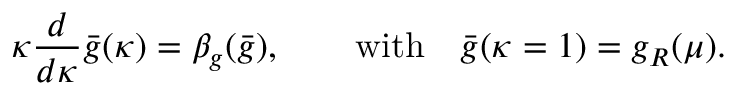Convert formula to latex. <formula><loc_0><loc_0><loc_500><loc_500>\kappa \frac { d } { d \kappa } \bar { g } ( \kappa ) = \beta _ { g } ( \bar { g } ) , \quad w i t h \quad \bar { g } ( \kappa = 1 ) = g _ { R } ( \mu ) .</formula> 